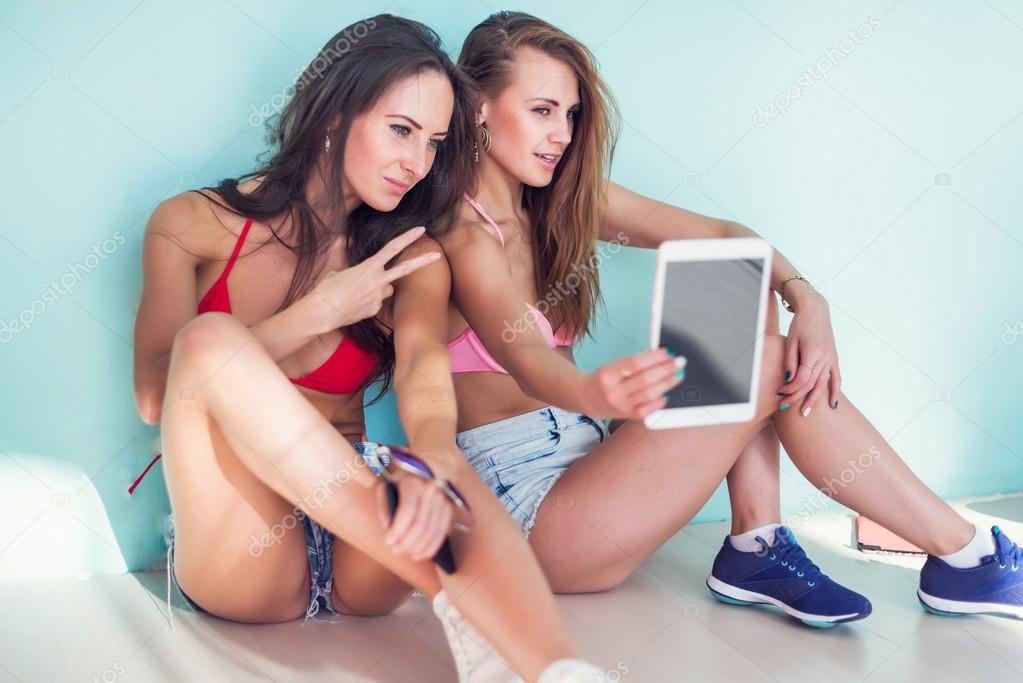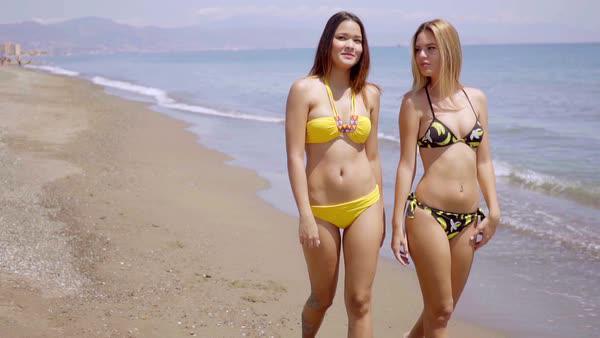The first image is the image on the left, the second image is the image on the right. Evaluate the accuracy of this statement regarding the images: "A female is wearing a yellow bikini.". Is it true? Answer yes or no. Yes. The first image is the image on the left, the second image is the image on the right. Assess this claim about the two images: "At least one woman has her hand on her hips.". Correct or not? Answer yes or no. No. 